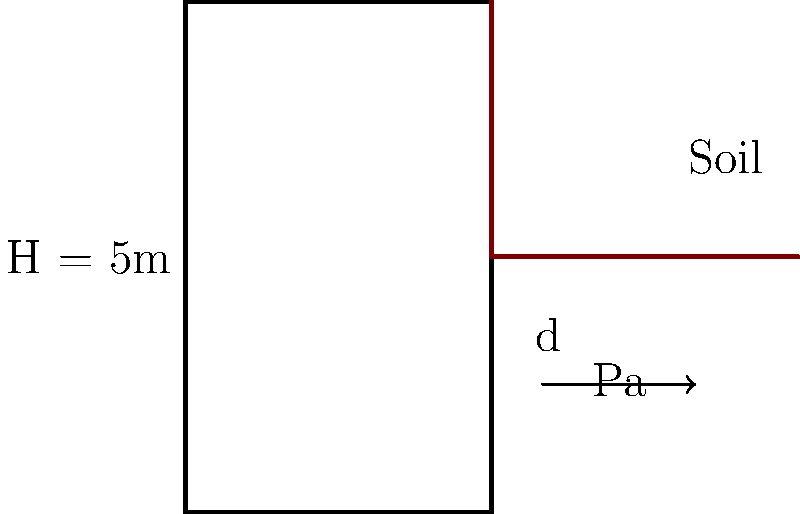A retaining wall is being designed to hold back a soil mass with a height of 5 meters. The soil has a unit weight of 18 kN/m³ and an internal friction angle of 30°. Using Rankine's theory for active earth pressure, calculate the required depth (d) of the retaining wall to ensure stability against overturning. Assume a factor of safety of 1.5 against overturning and neglect the weight of the wall itself. To solve this problem, we'll follow these steps:

1) Calculate the active earth pressure coefficient (Ka):
   $$K_a = \tan^2(45° - \frac{\phi}{2}) = \tan^2(45° - \frac{30°}{2}) = 0.333$$

2) Calculate the total active earth pressure (Pa):
   $$P_a = \frac{1}{2} \gamma H^2 K_a$$
   $$P_a = \frac{1}{2} \cdot 18 \cdot 5^2 \cdot 0.333 = 75 \text{ kN/m}$$

3) The point of application of Pa is at H/3 from the base:
   $$\text{Lever arm} = \frac{H}{3} = \frac{5}{3} = 1.67 \text{ m}$$

4) The overturning moment (Mo) is:
   $$M_o = P_a \cdot \frac{H}{3} = 75 \cdot 1.67 = 125 \text{ kNm/m}$$

5) The resisting moment (Mr) must be 1.5 times the overturning moment:
   $$M_r = 1.5 \cdot M_o = 1.5 \cdot 125 = 187.5 \text{ kNm/m}$$

6) The resisting moment is provided by the weight of the soil above the heel of the wall:
   $$M_r = \frac{1}{2} \gamma d^2 \cdot \frac{d}{3}$$
   $$187.5 = \frac{1}{6} \cdot 18 \cdot d^3$$

7) Solve for d:
   $$d^3 = \frac{187.5 \cdot 6}{18} = 62.5$$
   $$d = \sqrt[3]{62.5} = 3.97 \text{ m}$$

Therefore, the required depth of the retaining wall is approximately 3.97 meters.
Answer: 3.97 m 